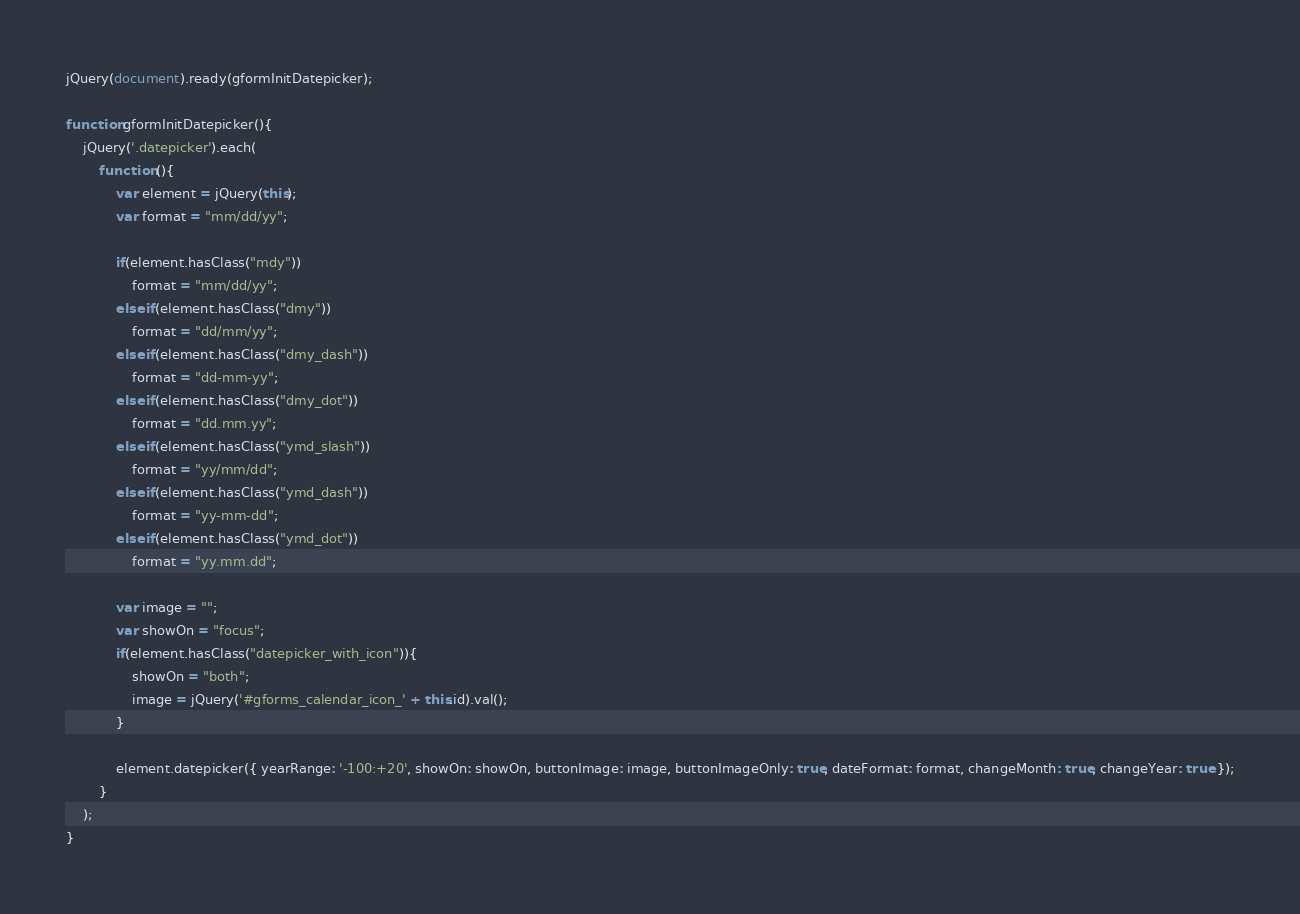<code> <loc_0><loc_0><loc_500><loc_500><_JavaScript_>jQuery(document).ready(gformInitDatepicker);

function gformInitDatepicker(){
    jQuery('.datepicker').each(
        function (){
            var element = jQuery(this);
            var format = "mm/dd/yy";

            if(element.hasClass("mdy"))
                format = "mm/dd/yy";
            else if(element.hasClass("dmy"))
                format = "dd/mm/yy";
            else if(element.hasClass("dmy_dash"))
                format = "dd-mm-yy";
            else if(element.hasClass("dmy_dot"))
                format = "dd.mm.yy";
            else if(element.hasClass("ymd_slash"))
                format = "yy/mm/dd";
            else if(element.hasClass("ymd_dash"))
                format = "yy-mm-dd";
            else if(element.hasClass("ymd_dot"))
                format = "yy.mm.dd";

            var image = "";
            var showOn = "focus";
            if(element.hasClass("datepicker_with_icon")){
                showOn = "both";
                image = jQuery('#gforms_calendar_icon_' + this.id).val();
            }

            element.datepicker({ yearRange: '-100:+20', showOn: showOn, buttonImage: image, buttonImageOnly: true, dateFormat: format, changeMonth: true, changeYear: true });
        }
    );
}

</code> 